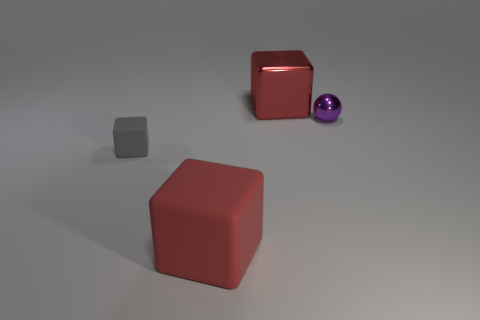What material is the large red cube left of the red object that is behind the large thing on the left side of the big metallic object? rubber 